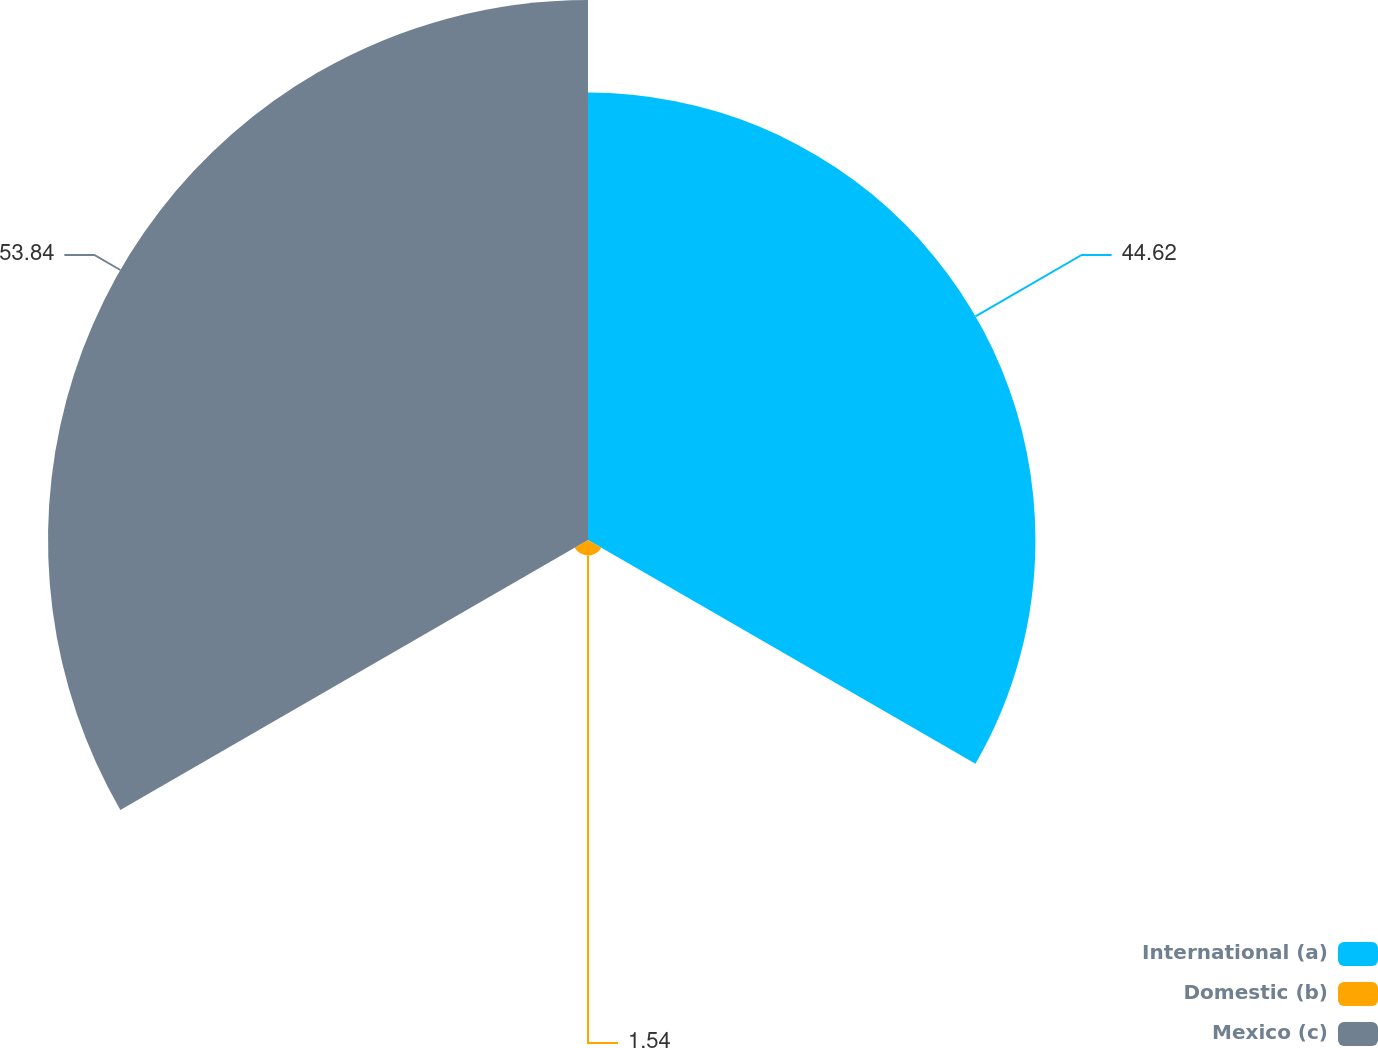Convert chart. <chart><loc_0><loc_0><loc_500><loc_500><pie_chart><fcel>International (a)<fcel>Domestic (b)<fcel>Mexico (c)<nl><fcel>44.62%<fcel>1.54%<fcel>53.85%<nl></chart> 